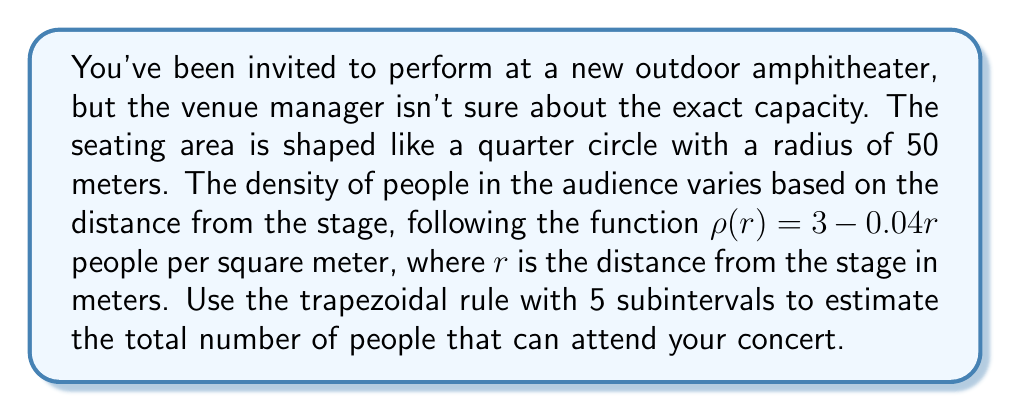Solve this math problem. To solve this problem, we'll use numerical integration with the trapezoidal rule. Here's the step-by-step process:

1) The area we're integrating over is a quarter circle, so we need to use polar coordinates. The integral for the number of people is:

   $$N = \int_0^{50} \int_0^{\pi/2} \rho(r) \cdot r \, d\theta \, dr$$

2) Integrating over $\theta$ first gives us:

   $$N = \frac{\pi}{2} \int_0^{50} (3 - 0.04r) \cdot r \, dr$$

3) Now we apply the trapezoidal rule with 5 subintervals. The formula is:

   $$\int_a^b f(x) \, dx \approx \frac{h}{2}[f(x_0) + 2f(x_1) + 2f(x_2) + 2f(x_3) + 2f(x_4) + f(x_5)]$$

   where $h = (b-a)/n$, $n$ is the number of subintervals, and $x_i = a + ih$.

4) In our case, $a = 0$, $b = 50$, $n = 5$, so $h = 10$. The function we're integrating is:

   $$f(r) = \frac{\pi}{2}(3 - 0.04r) \cdot r$$

5) Calculate the function values:
   
   $f(0) = 0$
   $f(10) = \frac{\pi}{2}(3 - 0.4) \cdot 10 = 13.09$
   $f(20) = \frac{\pi}{2}(3 - 0.8) \cdot 20 = 21.99$
   $f(30) = \frac{\pi}{2}(3 - 1.2) \cdot 30 = 26.70$
   $f(40) = \frac{\pi}{2}(3 - 1.6) \cdot 40 = 27.22$
   $f(50) = \frac{\pi}{2}(3 - 2.0) \cdot 50 = 23.56$

6) Apply the trapezoidal rule:

   $$N \approx \frac{10}{2}[0 + 2(13.09) + 2(21.99) + 2(26.70) + 2(27.22) + 23.56]$$
   $$N \approx 5[0 + 26.18 + 43.98 + 53.40 + 54.44 + 23.56]$$
   $$N \approx 5(201.56) = 1007.8$$

7) Round to the nearest whole number, as we can't have a fractional person.
Answer: 1008 people 